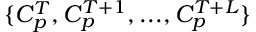<formula> <loc_0><loc_0><loc_500><loc_500>\{ C _ { p } ^ { T } , C _ { p } ^ { T + 1 } , \dots , C _ { p } ^ { T + L } \}</formula> 